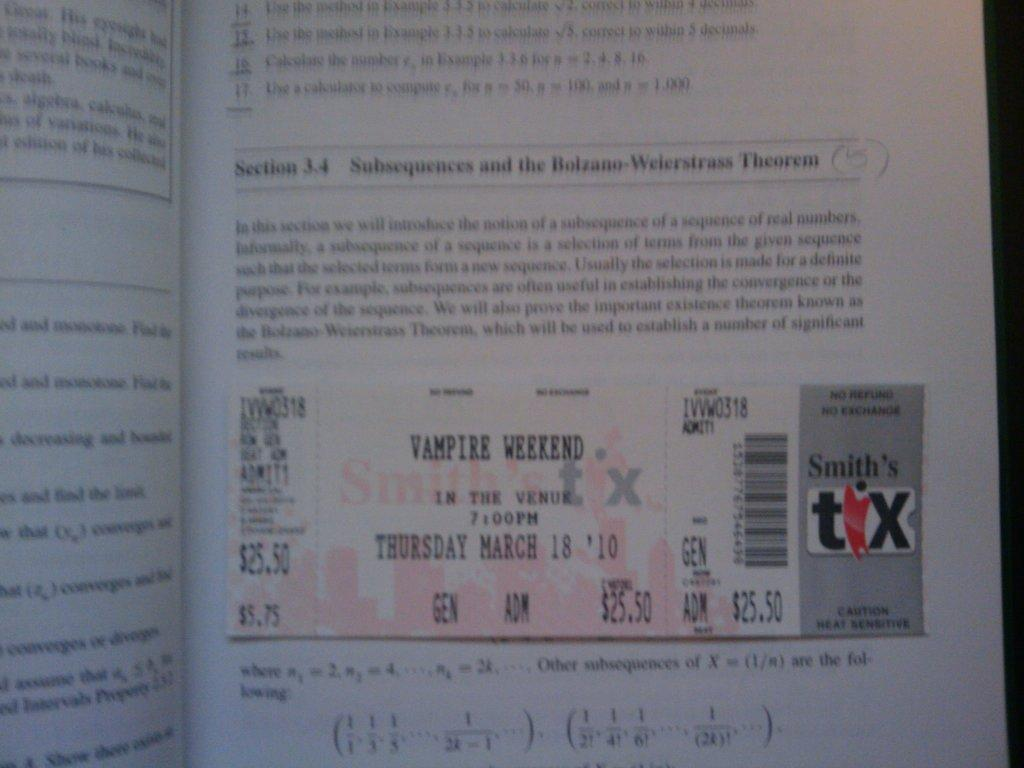What is the main subject of the image? The main subject of the image is a page. What can be found on the page? The page contains a coupon and text. What type of drug is mentioned on the page? There is no mention of any drug on the page; it contains a coupon and text related to a different subject. 